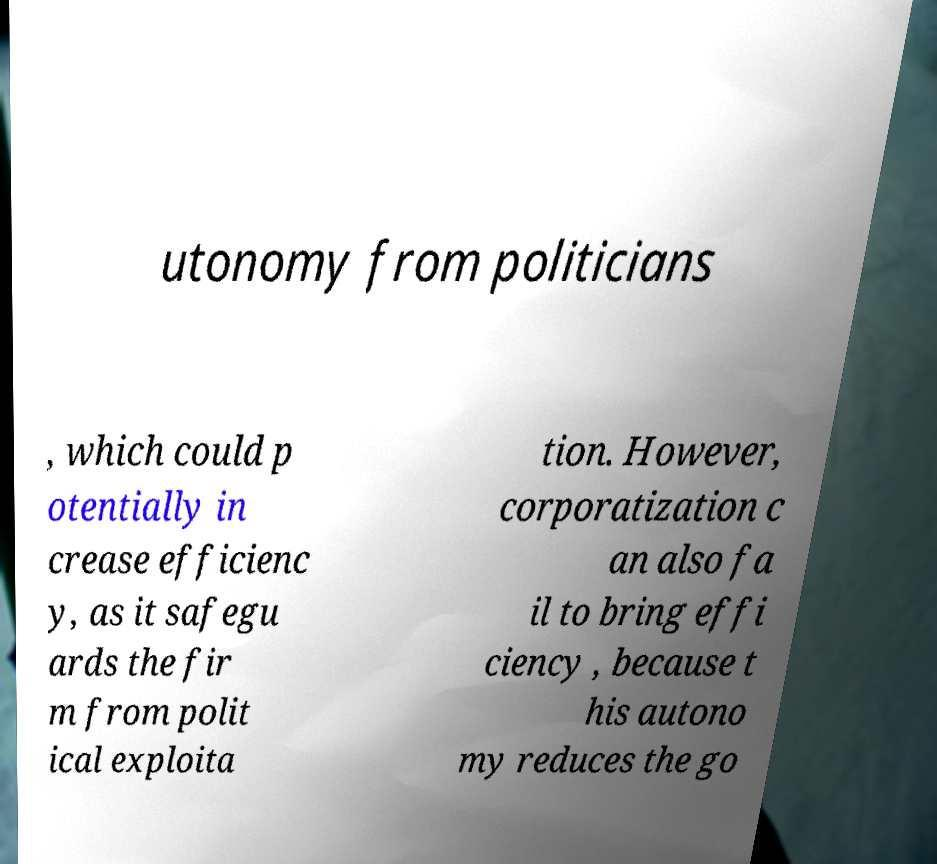Can you read and provide the text displayed in the image?This photo seems to have some interesting text. Can you extract and type it out for me? utonomy from politicians , which could p otentially in crease efficienc y, as it safegu ards the fir m from polit ical exploita tion. However, corporatization c an also fa il to bring effi ciency , because t his autono my reduces the go 